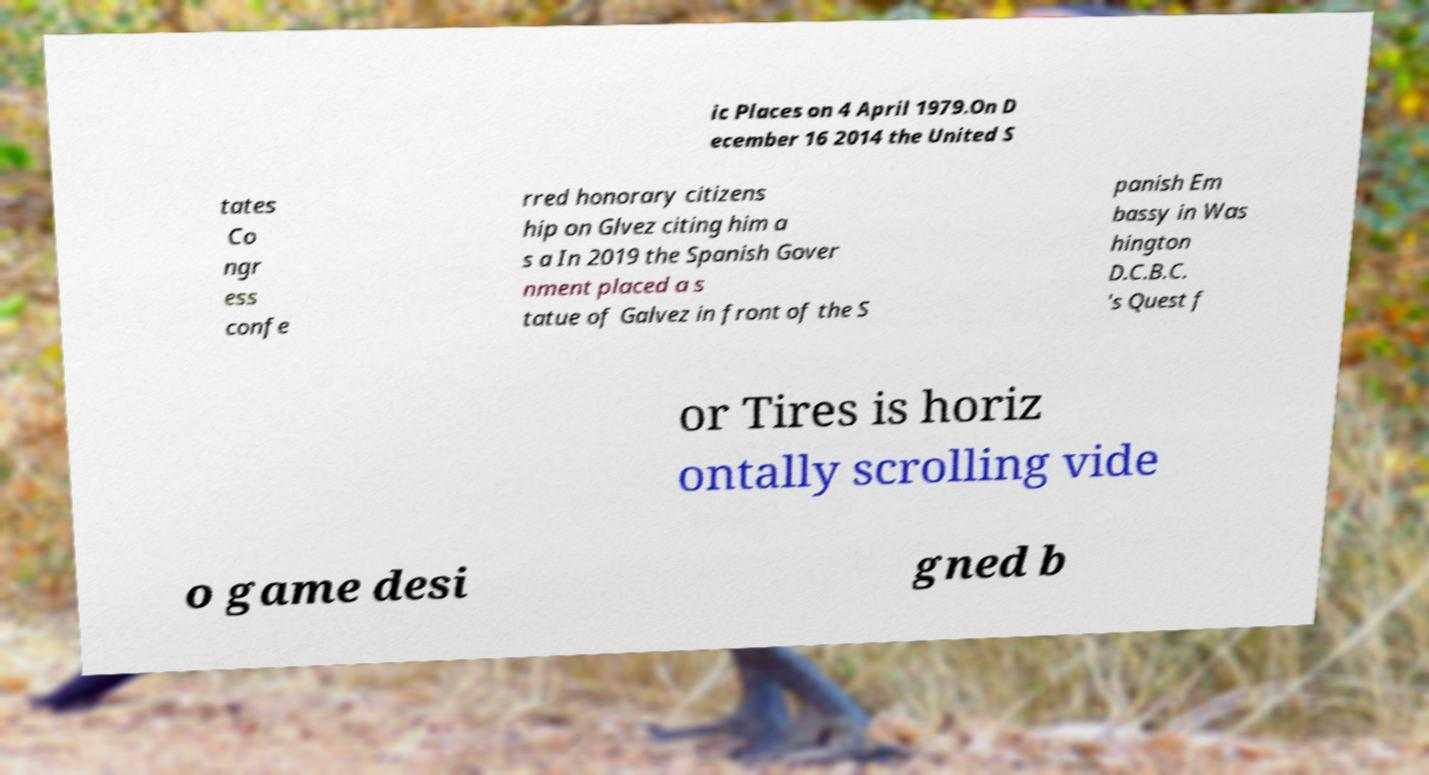Could you extract and type out the text from this image? ic Places on 4 April 1979.On D ecember 16 2014 the United S tates Co ngr ess confe rred honorary citizens hip on Glvez citing him a s a In 2019 the Spanish Gover nment placed a s tatue of Galvez in front of the S panish Em bassy in Was hington D.C.B.C. 's Quest f or Tires is horiz ontally scrolling vide o game desi gned b 